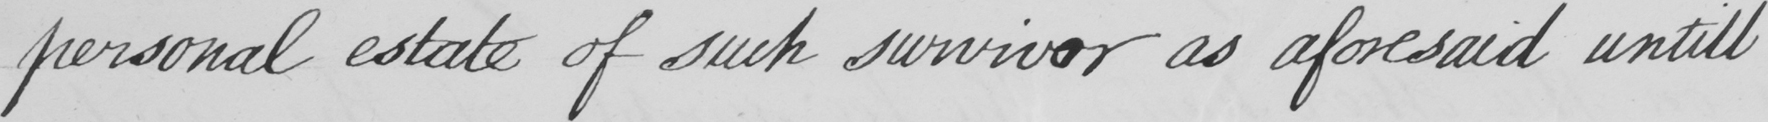What text is written in this handwritten line? personal estate of such survivor as aforesaid untill 